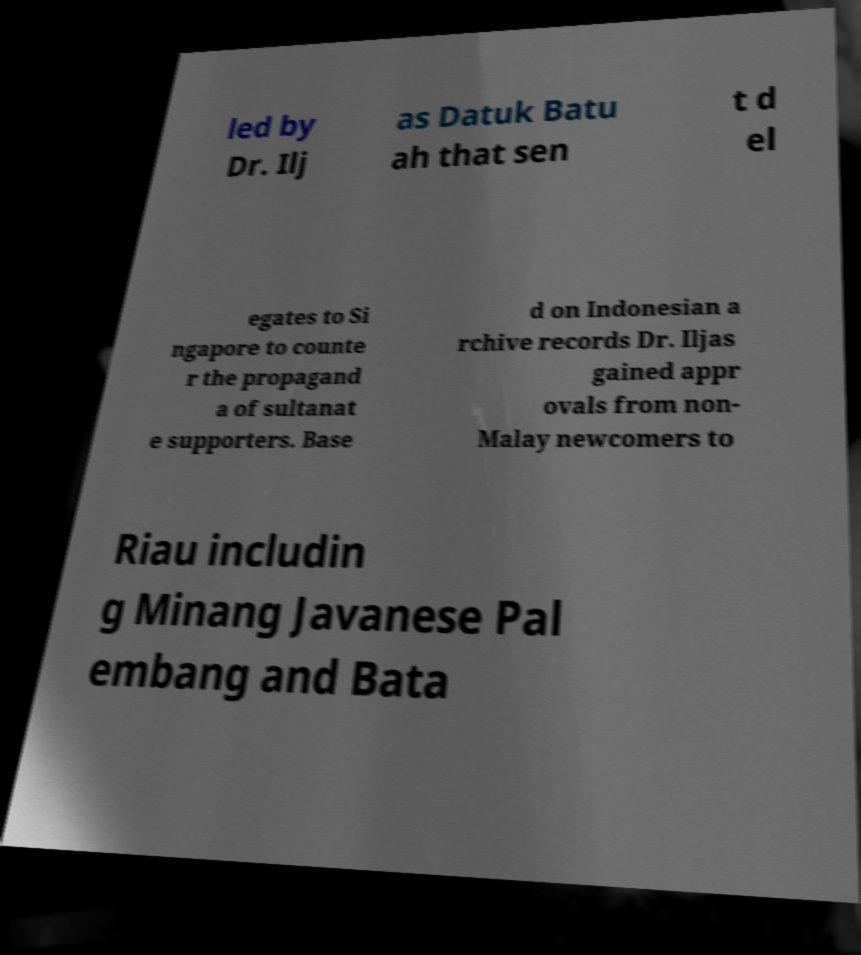For documentation purposes, I need the text within this image transcribed. Could you provide that? led by Dr. Ilj as Datuk Batu ah that sen t d el egates to Si ngapore to counte r the propagand a of sultanat e supporters. Base d on Indonesian a rchive records Dr. Iljas gained appr ovals from non- Malay newcomers to Riau includin g Minang Javanese Pal embang and Bata 